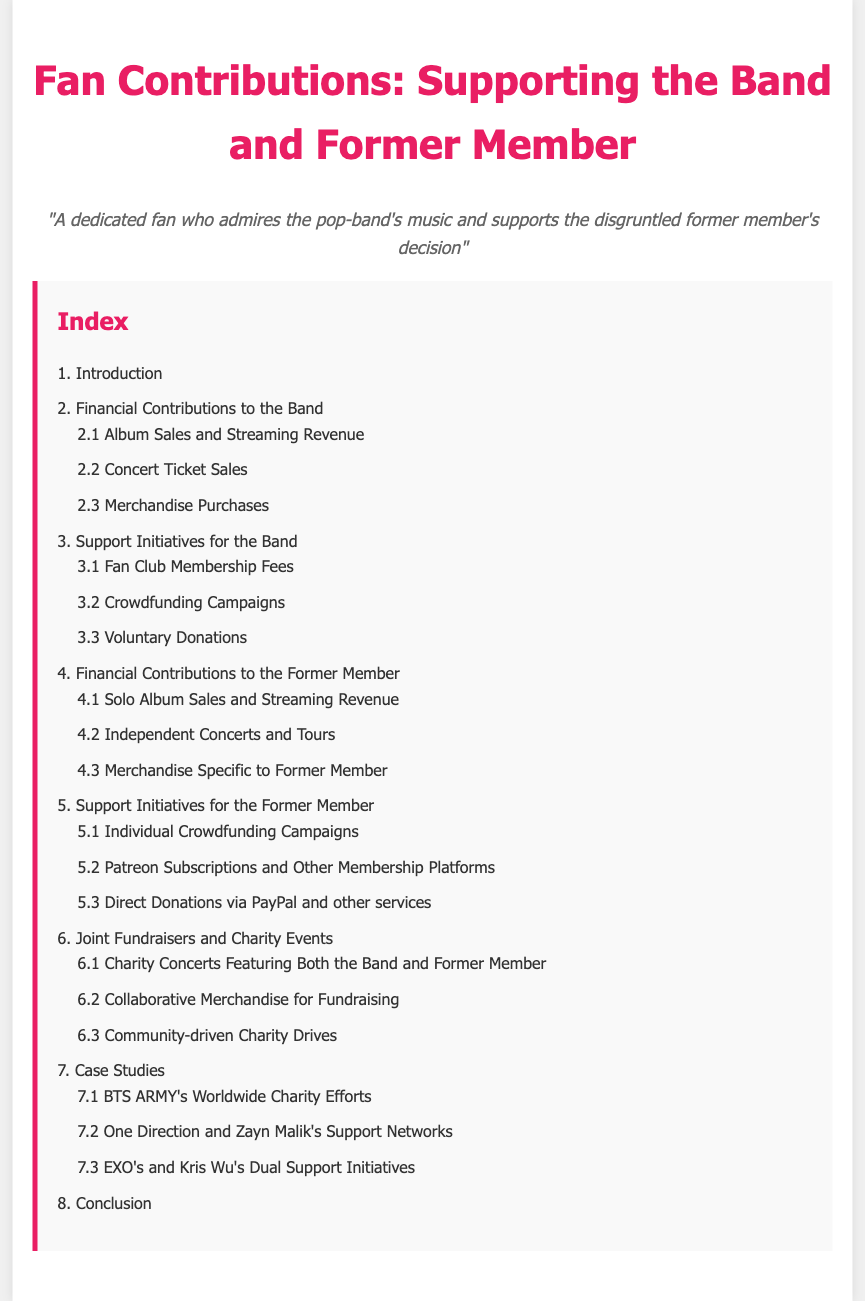What are the main financial contributions to the band? The main financial contributions to the band include album sales, concert ticket sales, and merchandise purchases.
Answer: Album sales, concert ticket sales, merchandise purchases What is the first support initiative mentioned for the band? The first support initiative for the band listed in the index is fan club membership fees.
Answer: Fan club membership fees How many types of financial contributions are listed for the former member? There are three types of financial contributions listed for the former member in the index.
Answer: Three What is one of the support initiatives for the former member? One of the support initiatives for the former member mentioned is individual crowdfunding campaigns.
Answer: Individual crowdfunding campaigns What section discusses joint fundraisers? The section that discusses joint fundraisers is titled "Joint Fundraisers and Charity Events."
Answer: Joint Fundraisers and Charity Events What is the last section mentioned in the document? The last section mentioned in the document is the conclusion.
Answer: Conclusion How many case studies are listed in the index? There are three case studies listed in the index.
Answer: Three What type of contributions does the document focus on? The document focuses on financial contributions and support initiatives.
Answer: Financial contributions and support initiatives 